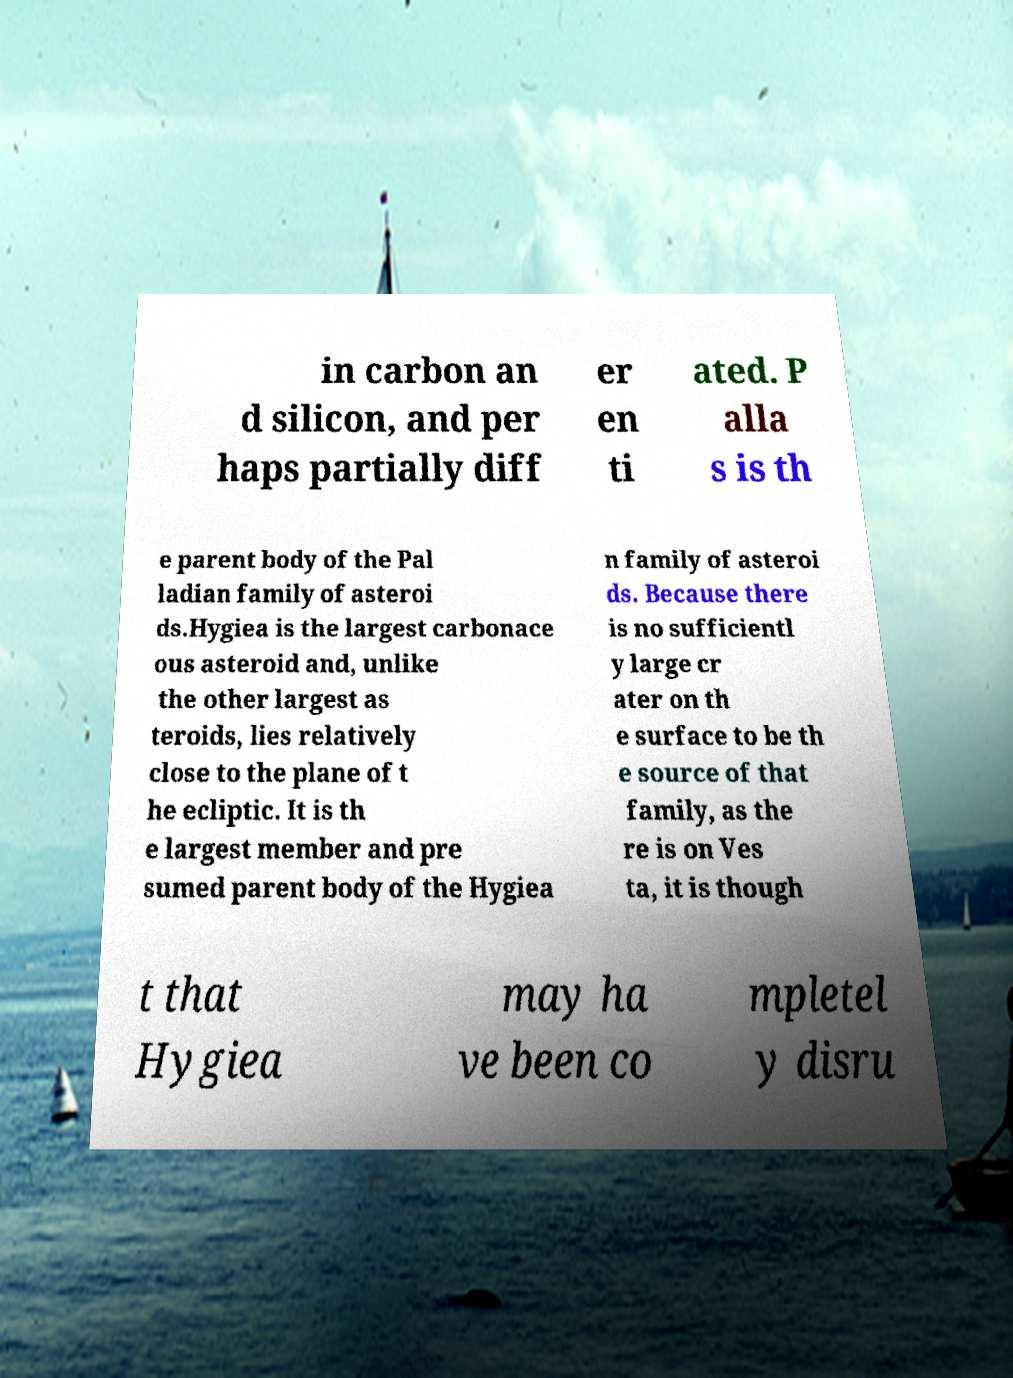Can you accurately transcribe the text from the provided image for me? in carbon an d silicon, and per haps partially diff er en ti ated. P alla s is th e parent body of the Pal ladian family of asteroi ds.Hygiea is the largest carbonace ous asteroid and, unlike the other largest as teroids, lies relatively close to the plane of t he ecliptic. It is th e largest member and pre sumed parent body of the Hygiea n family of asteroi ds. Because there is no sufficientl y large cr ater on th e surface to be th e source of that family, as the re is on Ves ta, it is though t that Hygiea may ha ve been co mpletel y disru 